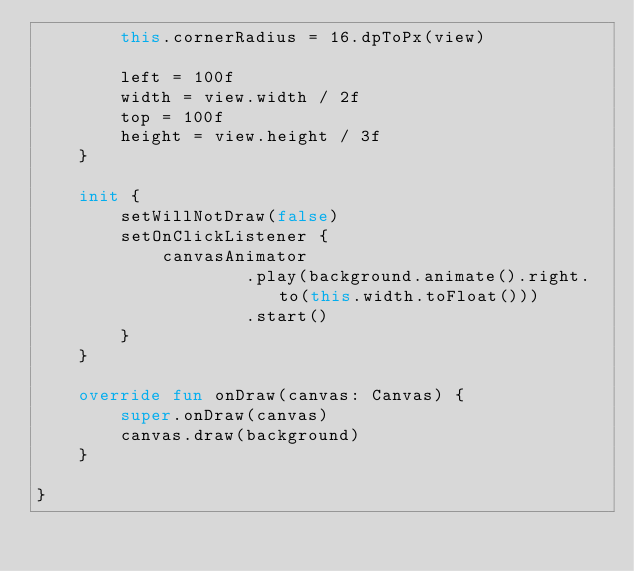Convert code to text. <code><loc_0><loc_0><loc_500><loc_500><_Kotlin_>        this.cornerRadius = 16.dpToPx(view)

        left = 100f
        width = view.width / 2f
        top = 100f
        height = view.height / 3f
    }

    init {
        setWillNotDraw(false)
        setOnClickListener {
            canvasAnimator
                    .play(background.animate().right.to(this.width.toFloat()))
                    .start()
        }
    }

    override fun onDraw(canvas: Canvas) {
        super.onDraw(canvas)
        canvas.draw(background)
    }

}
</code> 